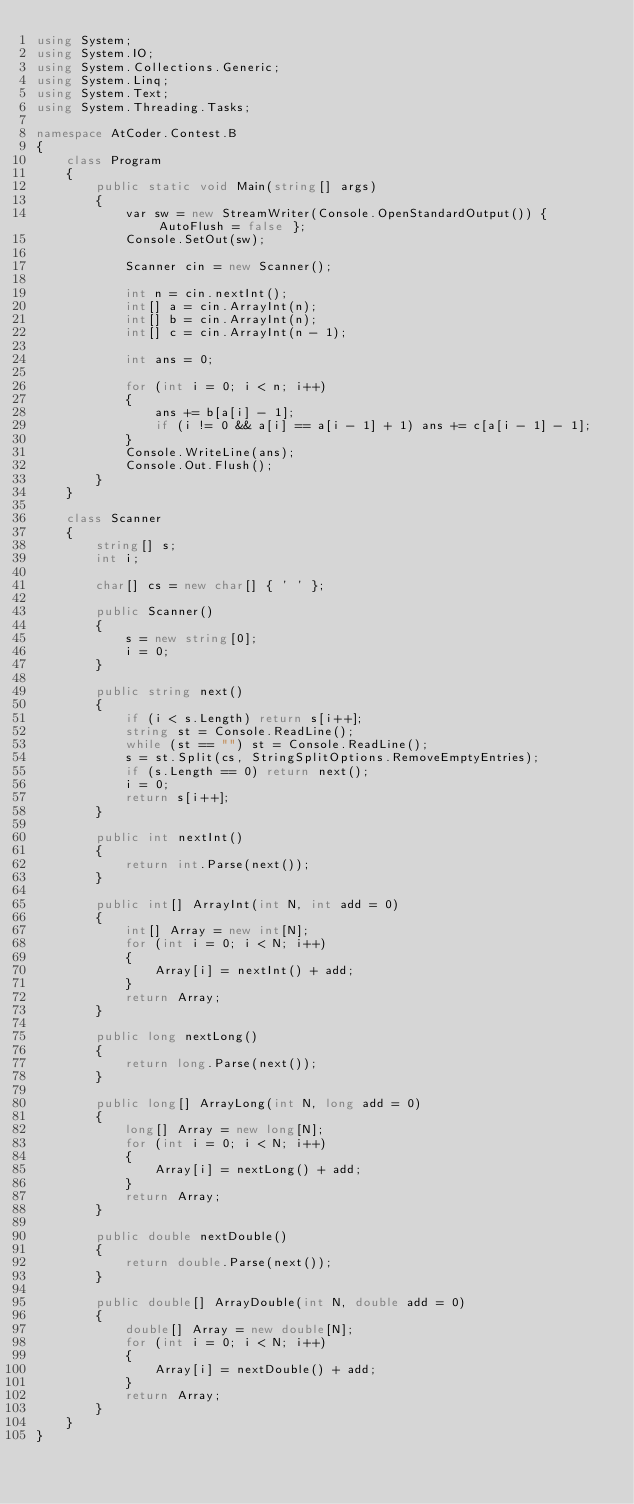<code> <loc_0><loc_0><loc_500><loc_500><_C#_>using System;
using System.IO;
using System.Collections.Generic;
using System.Linq;
using System.Text;
using System.Threading.Tasks;

namespace AtCoder.Contest.B
{
	class Program
	{
		public static void Main(string[] args)
		{
			var sw = new StreamWriter(Console.OpenStandardOutput()) { AutoFlush = false };
			Console.SetOut(sw);

			Scanner cin = new Scanner();

			int n = cin.nextInt();
			int[] a = cin.ArrayInt(n);
			int[] b = cin.ArrayInt(n);
			int[] c = cin.ArrayInt(n - 1);

			int ans = 0;

			for (int i = 0; i < n; i++)
			{
				ans += b[a[i] - 1];
				if (i != 0 && a[i] == a[i - 1] + 1) ans += c[a[i - 1] - 1];
			}
			Console.WriteLine(ans);
			Console.Out.Flush();
		}
	}

	class Scanner
	{
		string[] s;
		int i;

		char[] cs = new char[] { ' ' };

		public Scanner()
		{
			s = new string[0];
			i = 0;
		}

		public string next()
		{
			if (i < s.Length) return s[i++];
			string st = Console.ReadLine();
			while (st == "") st = Console.ReadLine();
			s = st.Split(cs, StringSplitOptions.RemoveEmptyEntries);
			if (s.Length == 0) return next();
			i = 0;
			return s[i++];
		}

		public int nextInt()
		{
			return int.Parse(next());
		}

		public int[] ArrayInt(int N, int add = 0)
		{
			int[] Array = new int[N];
			for (int i = 0; i < N; i++)
			{
				Array[i] = nextInt() + add;
			}
			return Array;
		}

		public long nextLong()
		{
			return long.Parse(next());
		}

		public long[] ArrayLong(int N, long add = 0)
		{
			long[] Array = new long[N];
			for (int i = 0; i < N; i++)
			{
				Array[i] = nextLong() + add;
			}
			return Array;
		}

		public double nextDouble()
		{
			return double.Parse(next());
		}

		public double[] ArrayDouble(int N, double add = 0)
		{
			double[] Array = new double[N];
			for (int i = 0; i < N; i++)
			{
				Array[i] = nextDouble() + add;
			}
			return Array;
		}
	}
}</code> 